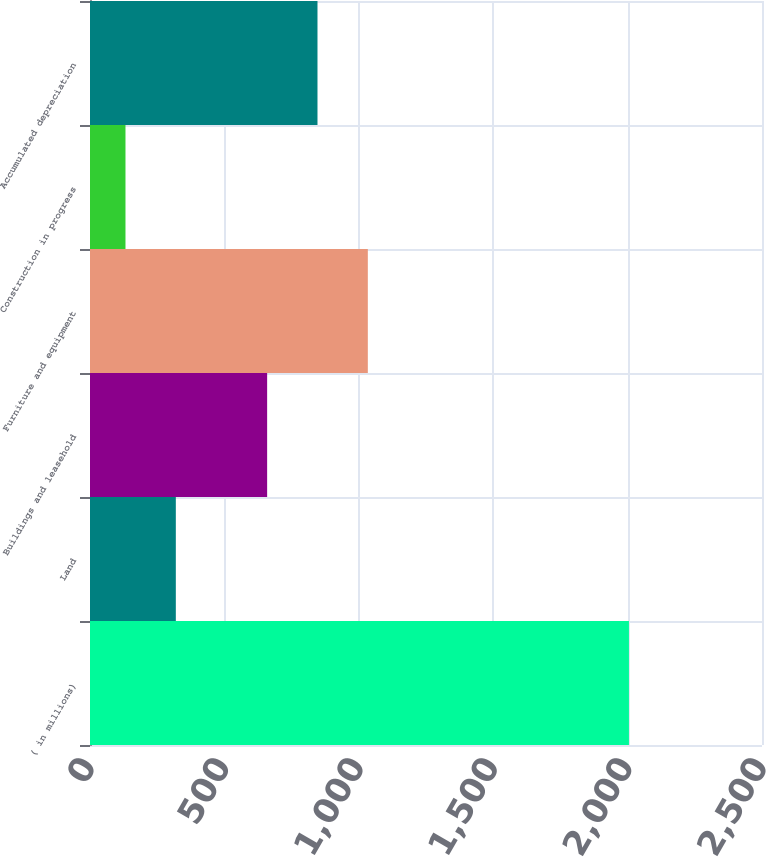Convert chart. <chart><loc_0><loc_0><loc_500><loc_500><bar_chart><fcel>( in millions)<fcel>Land<fcel>Buildings and leasehold<fcel>Furniture and equipment<fcel>Construction in progress<fcel>Accumulated depreciation<nl><fcel>2005<fcel>319.3<fcel>659<fcel>1033.6<fcel>132<fcel>846.3<nl></chart> 